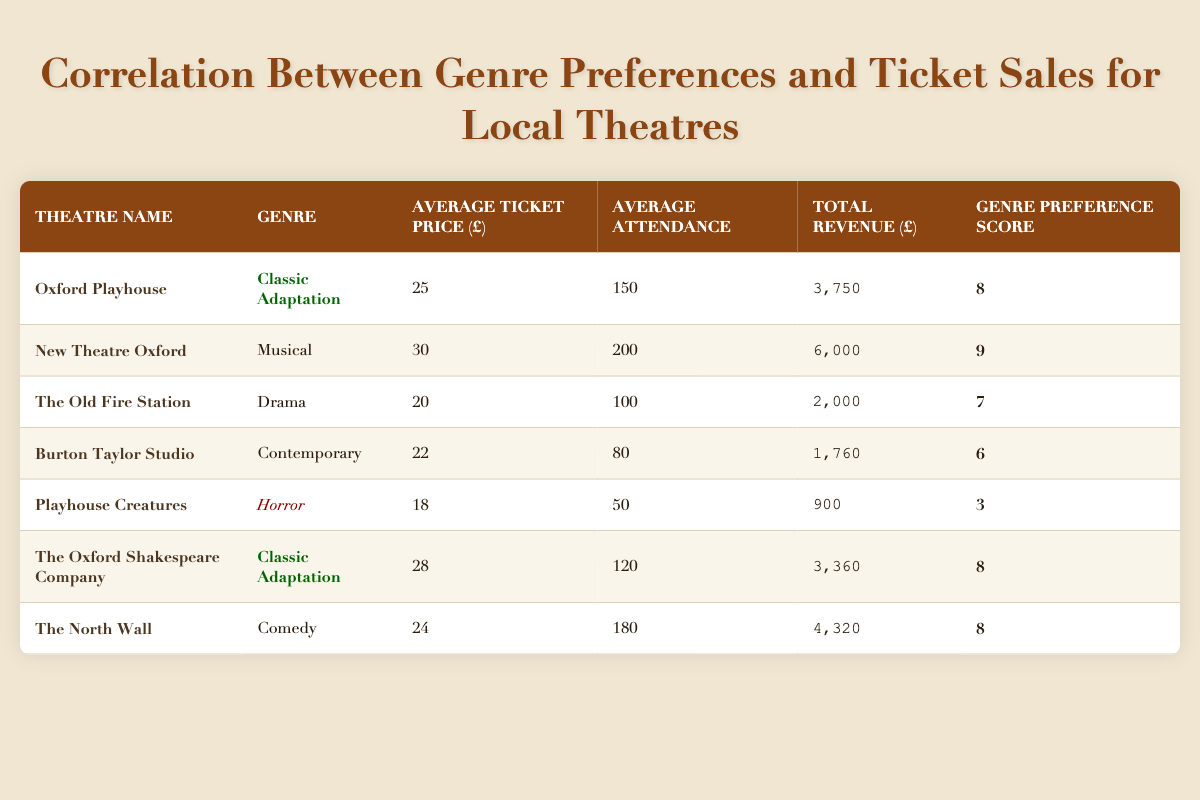What is the average ticket price for Classic Adaptation genre? The average ticket prices for the two theatres with the Classic Adaptation genre are 25 and 28. To find the average, we add them together (25 + 28 = 53) and then divide by the number of theatres (2). So, the average ticket price is 53/2 = 26.5.
Answer: 26.5 Which genre had the highest total revenue? The total revenue values are as follows: Classic Adaptation (3,750 + 3,360), Musical (6,000), Drama (2,000), Contemporary (1,760), Horror (900), and Comedy (4,320). The highest total revenue is from the Musical genre with 6,000.
Answer: Musical Is the genre preference score of Horror greater than 4? The genre preference score for Horror is 3, which is less than 4. Therefore, the answer is no.
Answer: No What is the total attendance for all theatres that perform Classic Adaptation? The average attendance for Classic Adaptation theatres are 150 (Oxford Playhouse) and 120 (The Oxford Shakespeare Company). We add these figures to calculate the total attendance, which is 150 + 120 = 270.
Answer: 270 Which genre has the lowest average attendance? The average attendance figures are: Classic Adaptation (150, 120), Musical (200), Drama (100), Contemporary (80), Horror (50), and Comedy (180). The genre with the lowest average attendance is Horror with 50.
Answer: Horror What is the combined total revenue of the theatres that feature Drama and Contemporary genres? The total revenue for Drama is 2,000 and for Contemporary it is 1,760. We add these two figures for the combined total revenue: 2,000 + 1,760 = 3,760.
Answer: 3,760 Is Playhouse Creatures the only theatre that features the Horror genre? Looking at the table, Playhouse Creatures is listed as the only theatre with the Horror genre. Therefore, the statement is true.
Answer: Yes What is the difference between the average ticket price for the Musical and the average ticket price for the Horror genre? The average ticket price for Musical is 30, and for Horror, it is 18. The difference is calculated as 30 - 18 = 12.
Answer: 12 